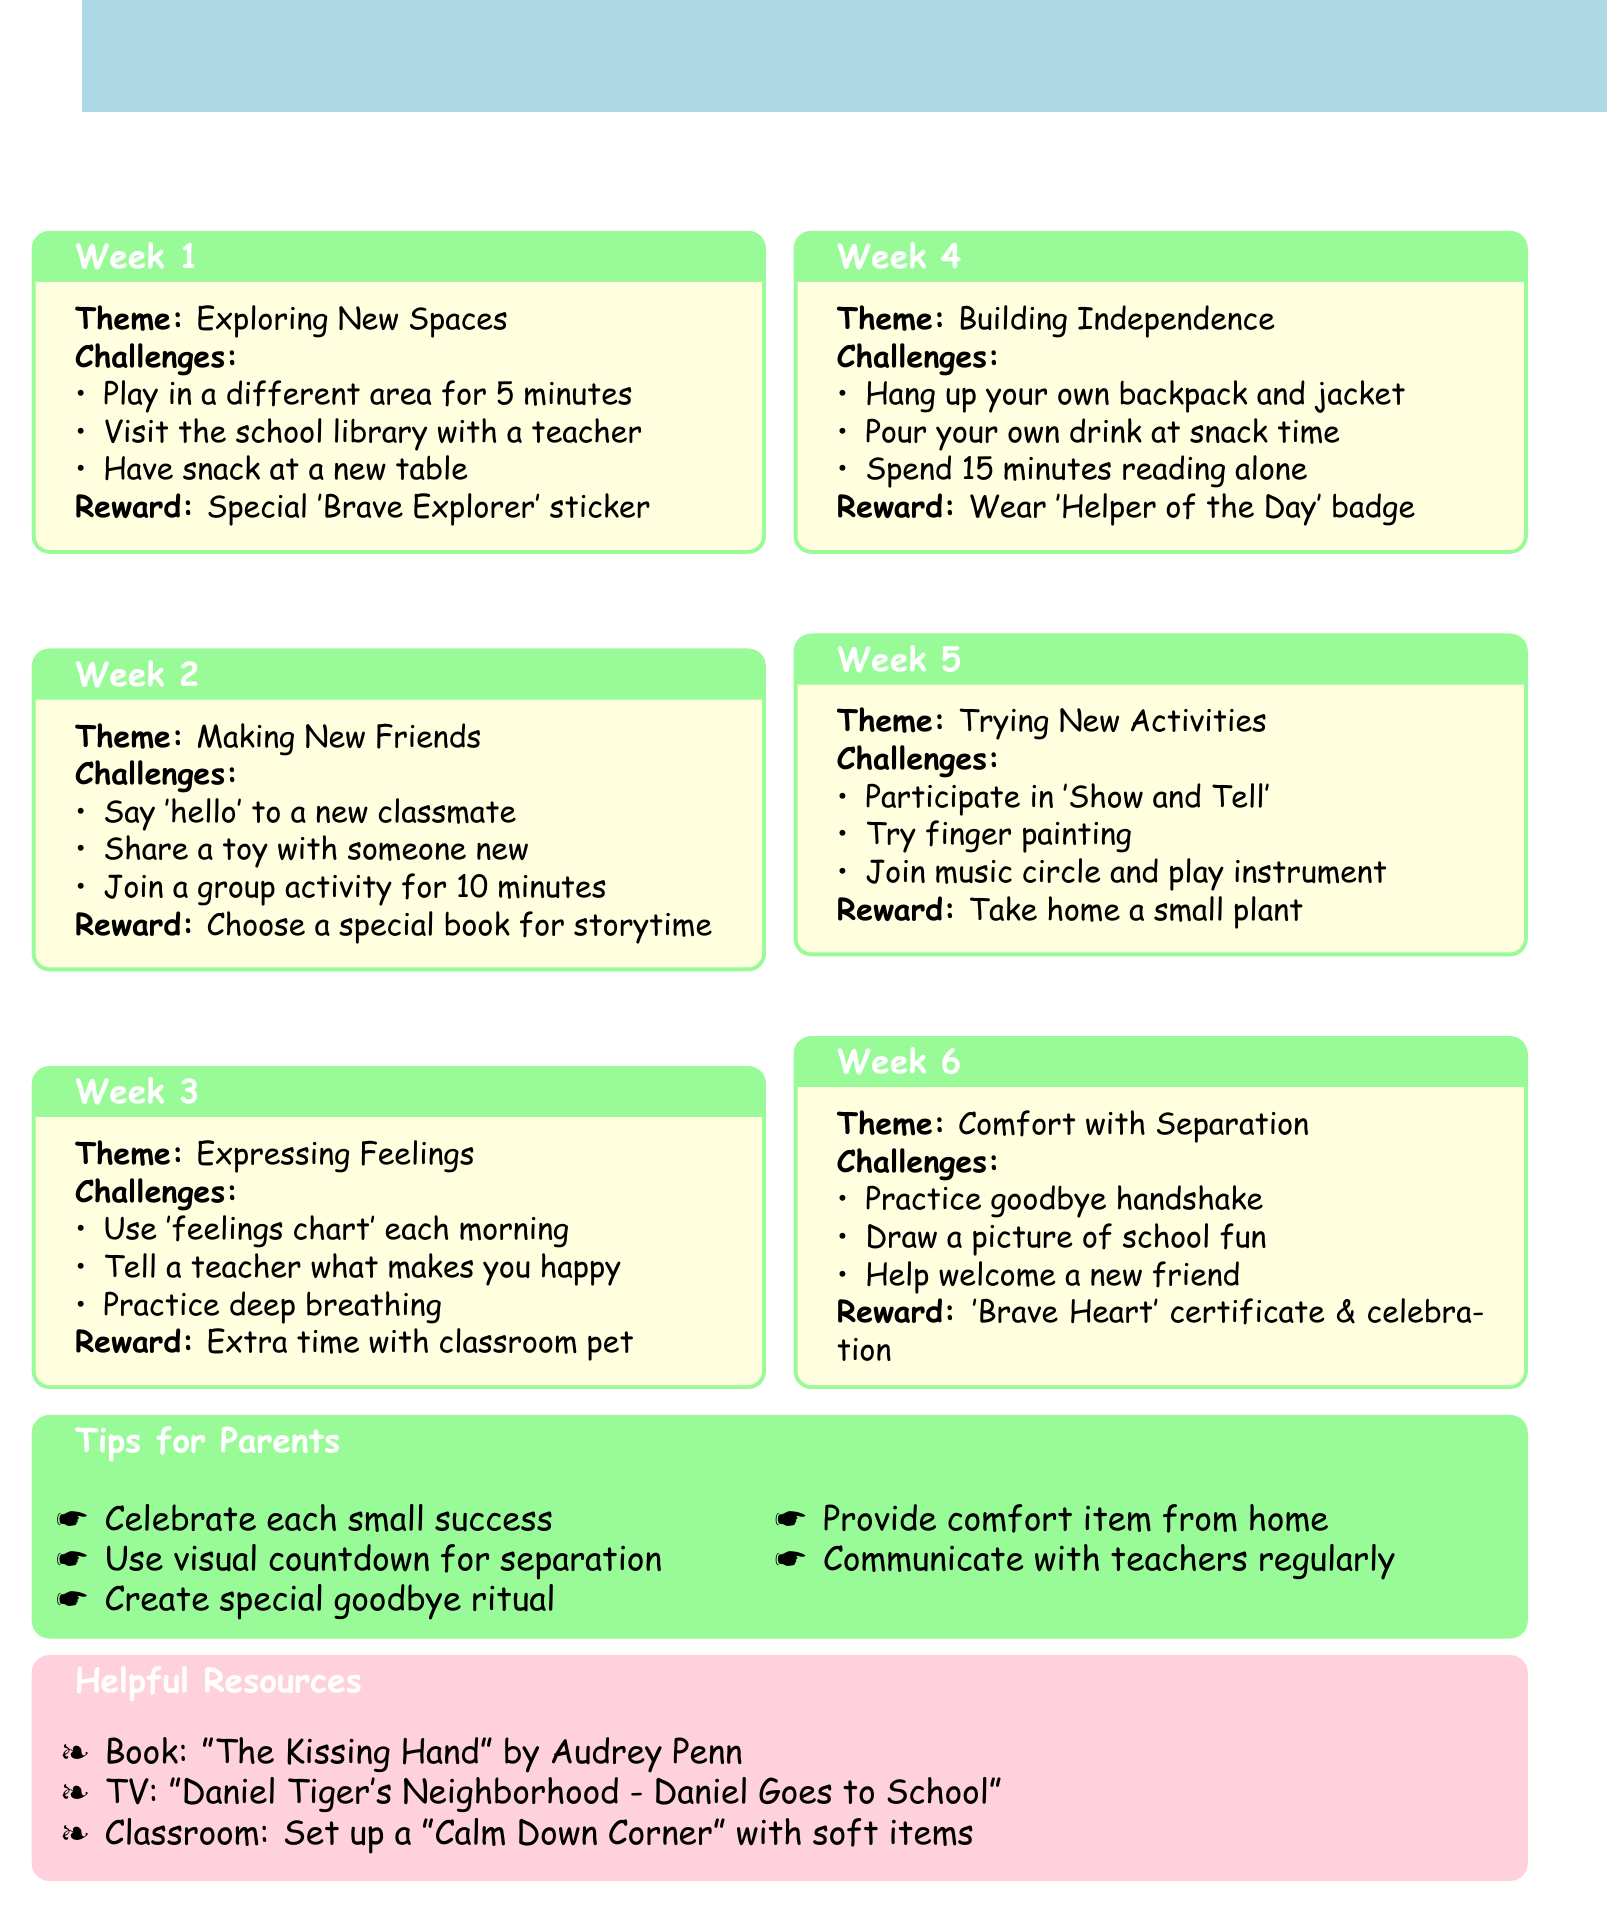What is the title of the chart? The title is specifically mentioned at the beginning of the document.
Answer: Brave Steps: Weekly Challenge Chart for Little Adventurers How many weeks are included in the challenges? The document lists a total of 6 weeks for challenges.
Answer: 6 What is the reward for week 5? The document states the specific reward for challenges completed in week 5.
Answer: Take home a small plant What theme is covered in week 3? The theme of each week is explicitly listed in the document.
Answer: Expressing Feelings What is one tip for parents mentioned in the document? The tips for parents are listed in a section that addresses various supportive actions they can take.
Answer: Celebrate each small success Which book is mentioned as a helpful resource? The document provides a title and author for recommended books.
Answer: The Kissing Hand by Audrey Penn How long should a preschooler spend in the reading corner alone during week 4? The required time for the challenge is stated in the document.
Answer: 15 minutes What is one of the challenges for week 2? The document details specific tasks for each week's challenges.
Answer: Say 'hello' to a new classmate 